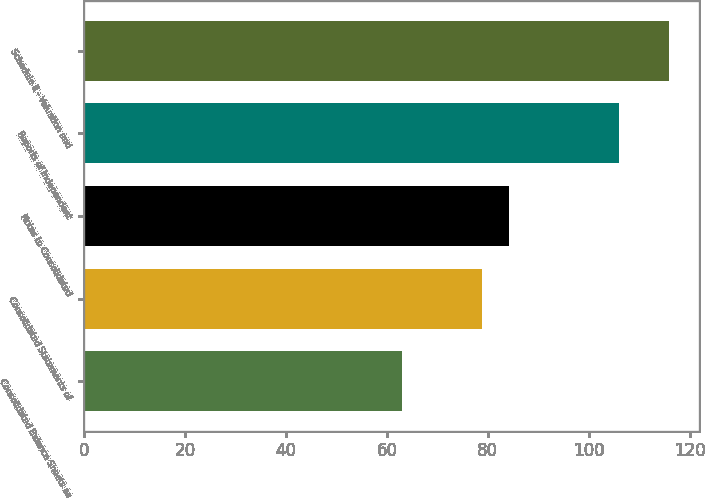Convert chart. <chart><loc_0><loc_0><loc_500><loc_500><bar_chart><fcel>Consolidated Balance Sheets as<fcel>Consolidated Statements of<fcel>Notes to Consolidated<fcel>Reports of Independent<fcel>Schedule II - Valuation and<nl><fcel>63<fcel>78.9<fcel>84.2<fcel>106<fcel>116<nl></chart> 